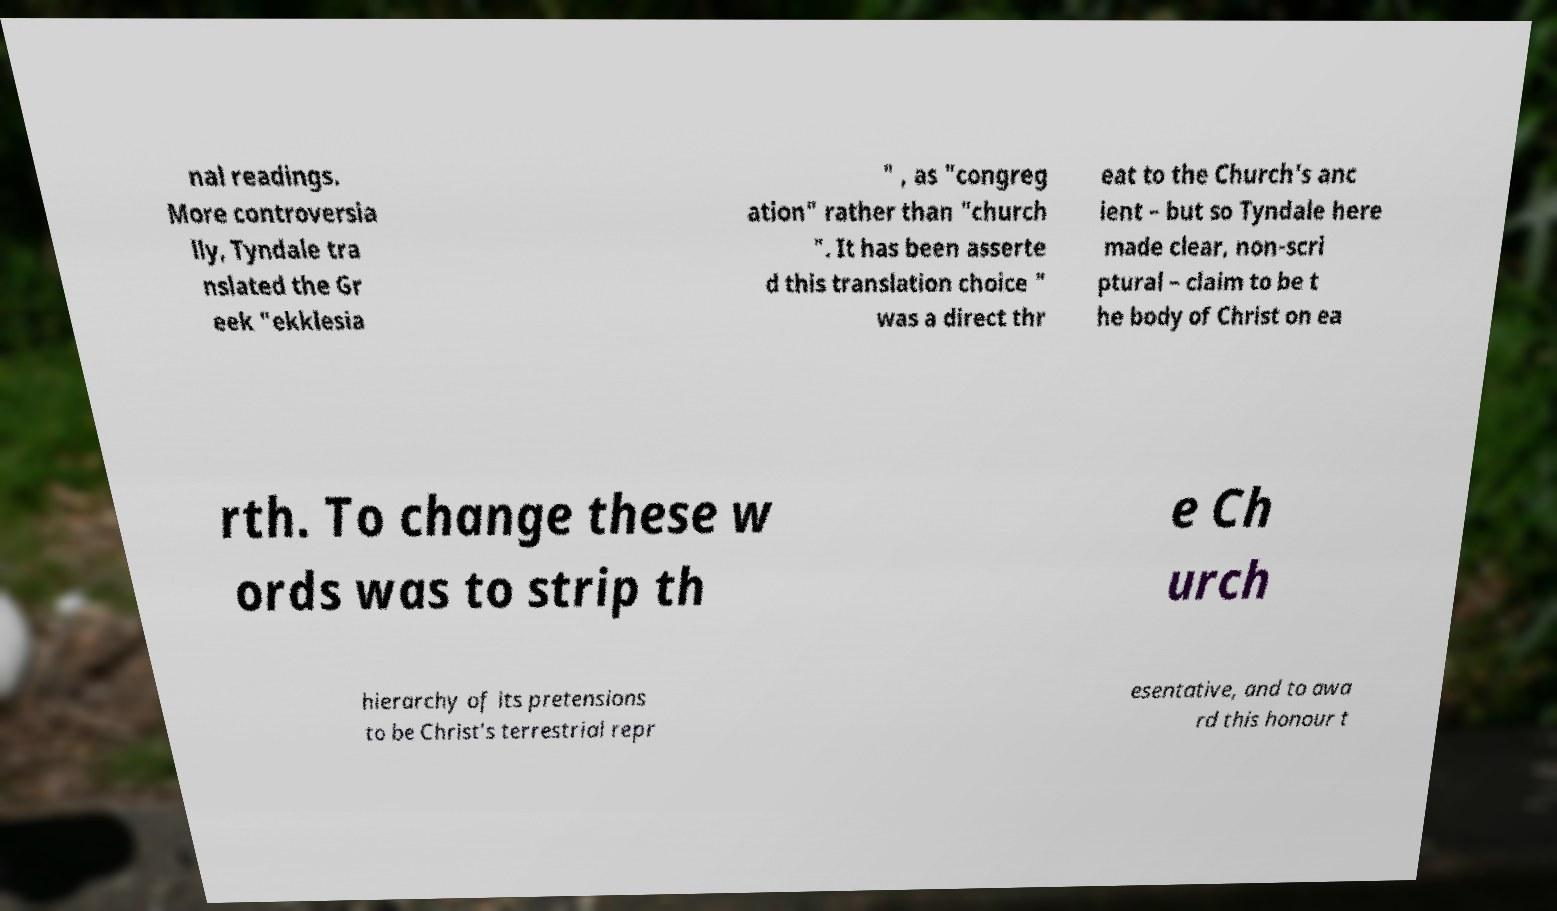What messages or text are displayed in this image? I need them in a readable, typed format. nal readings. More controversia lly, Tyndale tra nslated the Gr eek "ekklesia " , as "congreg ation" rather than "church ". It has been asserte d this translation choice " was a direct thr eat to the Church's anc ient – but so Tyndale here made clear, non-scri ptural – claim to be t he body of Christ on ea rth. To change these w ords was to strip th e Ch urch hierarchy of its pretensions to be Christ's terrestrial repr esentative, and to awa rd this honour t 